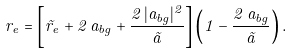<formula> <loc_0><loc_0><loc_500><loc_500>r _ { e } = \left [ \tilde { r } _ { e } + 2 \, a _ { b g } + \frac { 2 \, | a _ { b g } | ^ { 2 } } { \tilde { a } } \right ] \left ( 1 - \frac { 2 \, a _ { b g } } { \tilde { a } } \right ) .</formula> 